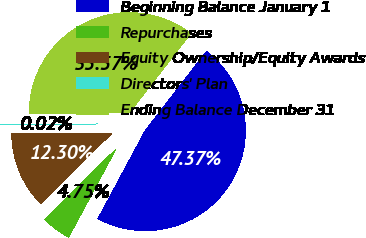<chart> <loc_0><loc_0><loc_500><loc_500><pie_chart><fcel>Beginning Balance January 1<fcel>Repurchases<fcel>Equity Ownership/Equity Awards<fcel>Directors' Plan<fcel>Ending Balance December 31<nl><fcel>47.37%<fcel>4.75%<fcel>12.3%<fcel>0.02%<fcel>35.57%<nl></chart> 